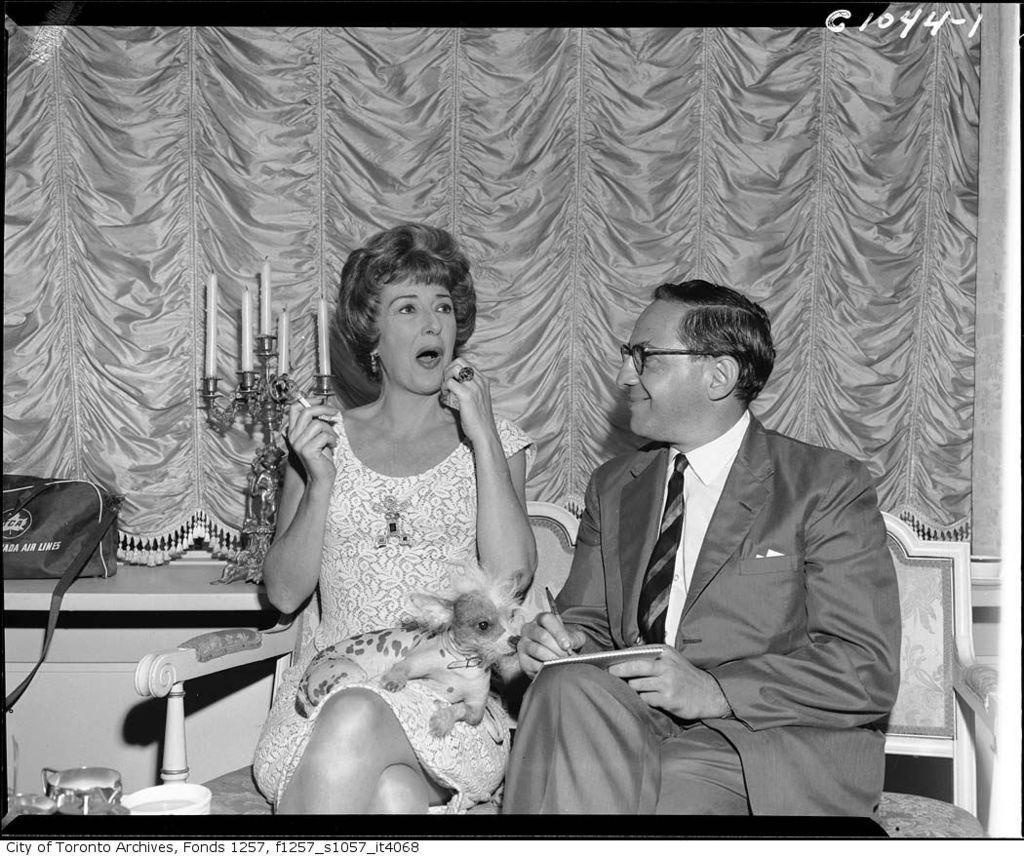In one or two sentences, can you explain what this image depicts? This is a black and white image and here we can see a man wearing glasses, a coat and a tie and holding some objects and a lady holding a cigarette are sitting on the sofa and we can see a dog. In the background, there are candles and we can see a curtain, a bag and some other objects. At the top, there is some text. 